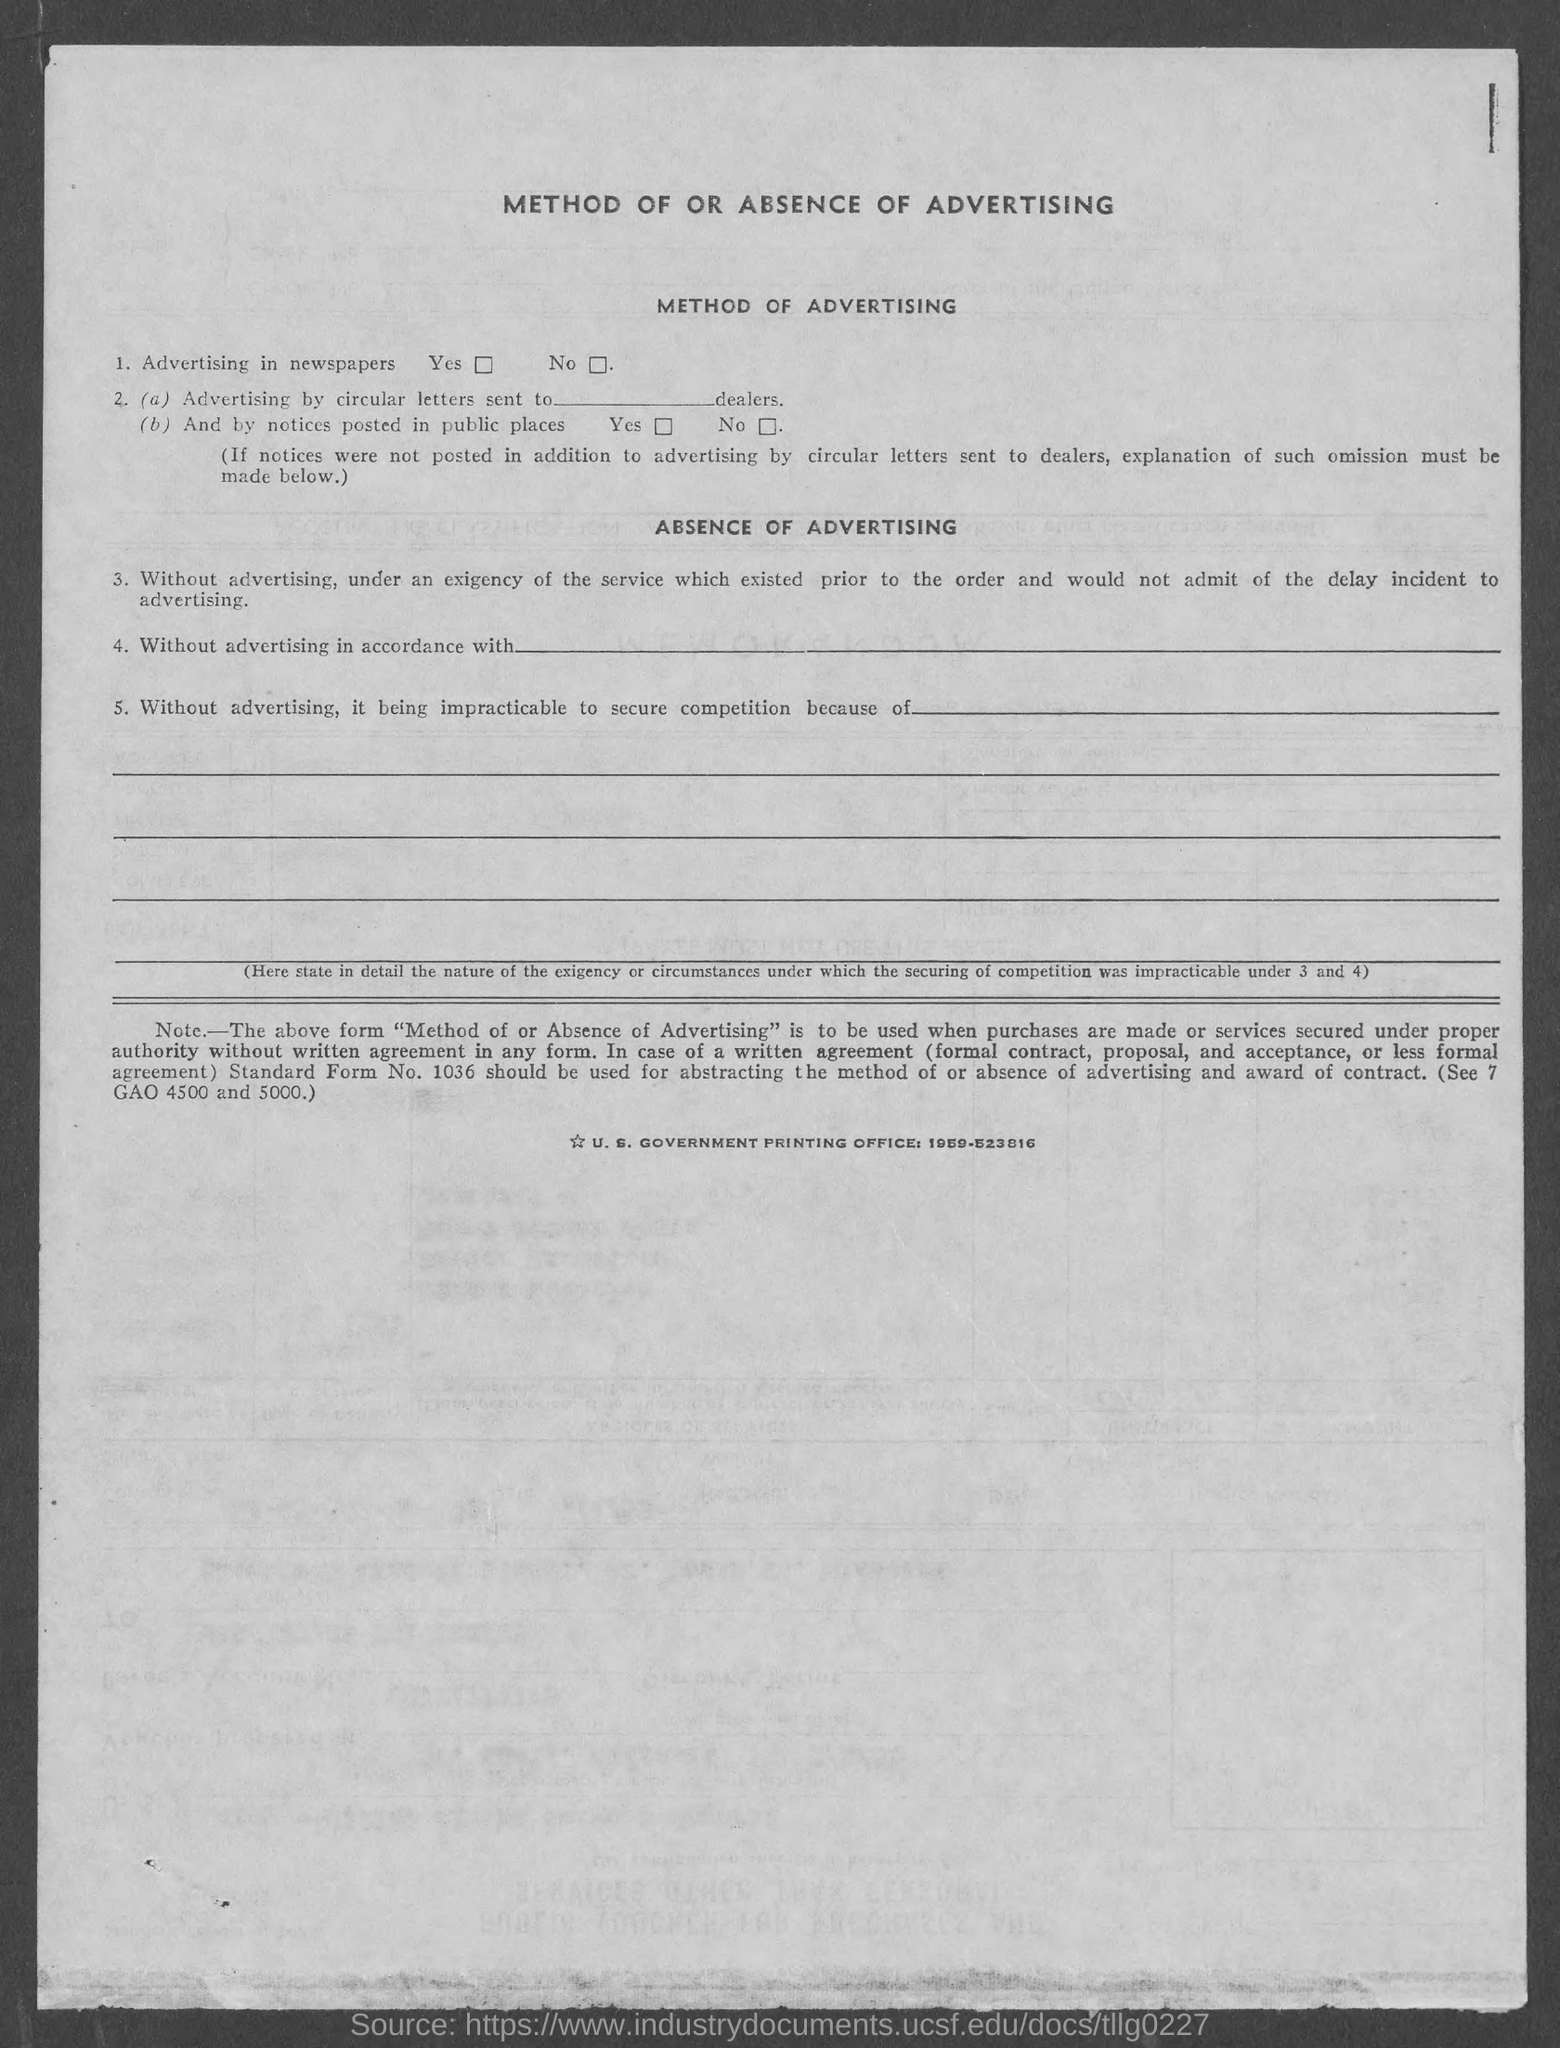What is the first title in the document?
Ensure brevity in your answer.  Method of or absence of advertising. What is the second title in the document?
Make the answer very short. Method of advertising. What is the third title in the document?
Give a very brief answer. Absence of advertising. 